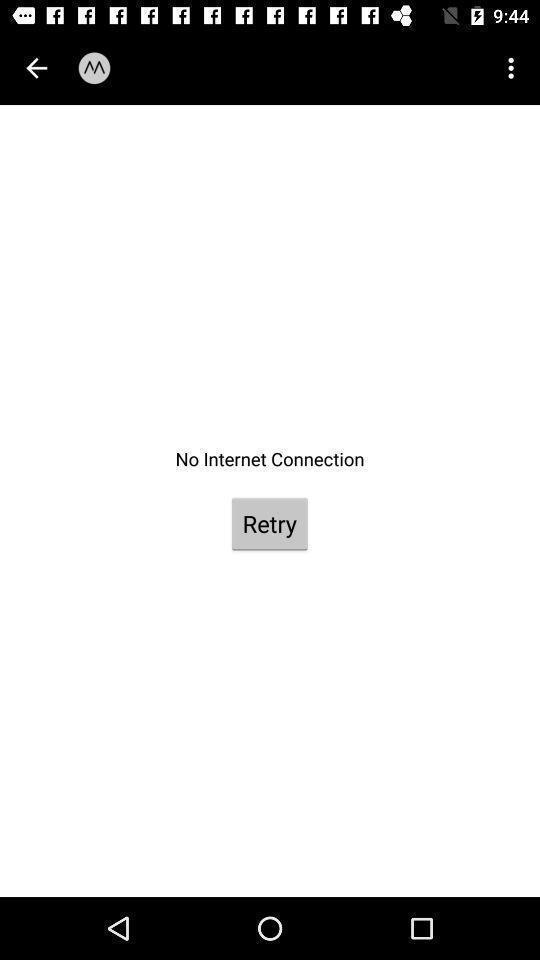Summarize the information in this screenshot. Page for retry connectivity. 